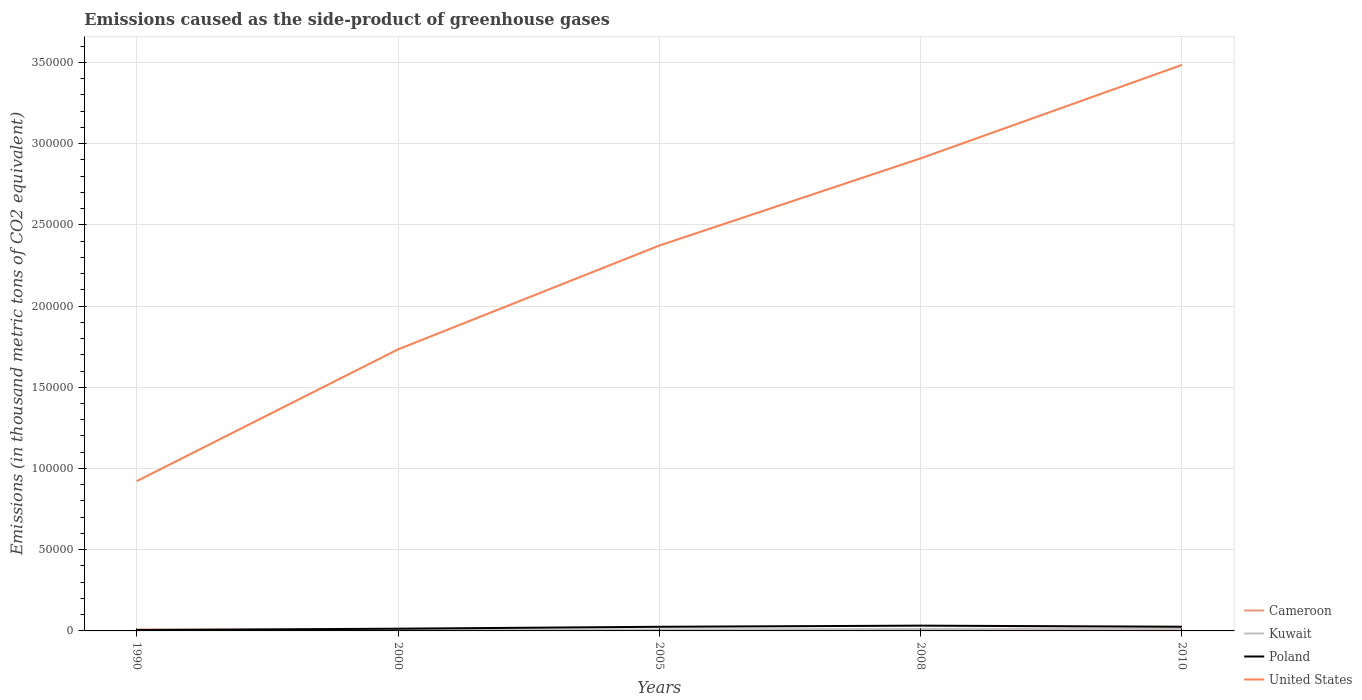Does the line corresponding to Cameroon intersect with the line corresponding to Poland?
Give a very brief answer. Yes. Is the number of lines equal to the number of legend labels?
Ensure brevity in your answer.  Yes. Across all years, what is the maximum emissions caused as the side-product of greenhouse gases in Poland?
Your answer should be very brief. 532.2. What is the total emissions caused as the side-product of greenhouse gases in Poland in the graph?
Your answer should be compact. -844.1. What is the difference between the highest and the second highest emissions caused as the side-product of greenhouse gases in Poland?
Ensure brevity in your answer.  2717.6. What is the difference between the highest and the lowest emissions caused as the side-product of greenhouse gases in Cameroon?
Give a very brief answer. 1. Are the values on the major ticks of Y-axis written in scientific E-notation?
Ensure brevity in your answer.  No. Does the graph contain any zero values?
Provide a short and direct response. No. Where does the legend appear in the graph?
Your response must be concise. Bottom right. How are the legend labels stacked?
Provide a succinct answer. Vertical. What is the title of the graph?
Provide a short and direct response. Emissions caused as the side-product of greenhouse gases. Does "Middle East & North Africa (developing only)" appear as one of the legend labels in the graph?
Offer a very short reply. No. What is the label or title of the X-axis?
Your answer should be very brief. Years. What is the label or title of the Y-axis?
Your answer should be very brief. Emissions (in thousand metric tons of CO2 equivalent). What is the Emissions (in thousand metric tons of CO2 equivalent) of Cameroon in 1990?
Ensure brevity in your answer.  932.3. What is the Emissions (in thousand metric tons of CO2 equivalent) of Kuwait in 1990?
Keep it short and to the point. 263.1. What is the Emissions (in thousand metric tons of CO2 equivalent) in Poland in 1990?
Your response must be concise. 532.2. What is the Emissions (in thousand metric tons of CO2 equivalent) in United States in 1990?
Give a very brief answer. 9.22e+04. What is the Emissions (in thousand metric tons of CO2 equivalent) in Cameroon in 2000?
Your answer should be compact. 514.7. What is the Emissions (in thousand metric tons of CO2 equivalent) of Kuwait in 2000?
Make the answer very short. 498.2. What is the Emissions (in thousand metric tons of CO2 equivalent) of Poland in 2000?
Offer a very short reply. 1376.3. What is the Emissions (in thousand metric tons of CO2 equivalent) in United States in 2000?
Offer a terse response. 1.73e+05. What is the Emissions (in thousand metric tons of CO2 equivalent) in Cameroon in 2005?
Ensure brevity in your answer.  417.5. What is the Emissions (in thousand metric tons of CO2 equivalent) of Kuwait in 2005?
Your answer should be very brief. 925.6. What is the Emissions (in thousand metric tons of CO2 equivalent) of Poland in 2005?
Offer a terse response. 2547.9. What is the Emissions (in thousand metric tons of CO2 equivalent) of United States in 2005?
Your response must be concise. 2.37e+05. What is the Emissions (in thousand metric tons of CO2 equivalent) in Cameroon in 2008?
Ensure brevity in your answer.  422.1. What is the Emissions (in thousand metric tons of CO2 equivalent) in Kuwait in 2008?
Offer a terse response. 1235.4. What is the Emissions (in thousand metric tons of CO2 equivalent) in Poland in 2008?
Provide a succinct answer. 3249.8. What is the Emissions (in thousand metric tons of CO2 equivalent) in United States in 2008?
Give a very brief answer. 2.91e+05. What is the Emissions (in thousand metric tons of CO2 equivalent) in Cameroon in 2010?
Keep it short and to the point. 353. What is the Emissions (in thousand metric tons of CO2 equivalent) in Kuwait in 2010?
Provide a succinct answer. 1451. What is the Emissions (in thousand metric tons of CO2 equivalent) of Poland in 2010?
Your response must be concise. 2582. What is the Emissions (in thousand metric tons of CO2 equivalent) of United States in 2010?
Your answer should be very brief. 3.48e+05. Across all years, what is the maximum Emissions (in thousand metric tons of CO2 equivalent) of Cameroon?
Give a very brief answer. 932.3. Across all years, what is the maximum Emissions (in thousand metric tons of CO2 equivalent) in Kuwait?
Ensure brevity in your answer.  1451. Across all years, what is the maximum Emissions (in thousand metric tons of CO2 equivalent) in Poland?
Make the answer very short. 3249.8. Across all years, what is the maximum Emissions (in thousand metric tons of CO2 equivalent) of United States?
Give a very brief answer. 3.48e+05. Across all years, what is the minimum Emissions (in thousand metric tons of CO2 equivalent) of Cameroon?
Make the answer very short. 353. Across all years, what is the minimum Emissions (in thousand metric tons of CO2 equivalent) of Kuwait?
Your answer should be very brief. 263.1. Across all years, what is the minimum Emissions (in thousand metric tons of CO2 equivalent) in Poland?
Make the answer very short. 532.2. Across all years, what is the minimum Emissions (in thousand metric tons of CO2 equivalent) of United States?
Your response must be concise. 9.22e+04. What is the total Emissions (in thousand metric tons of CO2 equivalent) in Cameroon in the graph?
Your answer should be compact. 2639.6. What is the total Emissions (in thousand metric tons of CO2 equivalent) of Kuwait in the graph?
Give a very brief answer. 4373.3. What is the total Emissions (in thousand metric tons of CO2 equivalent) of Poland in the graph?
Your answer should be very brief. 1.03e+04. What is the total Emissions (in thousand metric tons of CO2 equivalent) of United States in the graph?
Your answer should be very brief. 1.14e+06. What is the difference between the Emissions (in thousand metric tons of CO2 equivalent) of Cameroon in 1990 and that in 2000?
Your response must be concise. 417.6. What is the difference between the Emissions (in thousand metric tons of CO2 equivalent) in Kuwait in 1990 and that in 2000?
Give a very brief answer. -235.1. What is the difference between the Emissions (in thousand metric tons of CO2 equivalent) in Poland in 1990 and that in 2000?
Provide a short and direct response. -844.1. What is the difference between the Emissions (in thousand metric tons of CO2 equivalent) in United States in 1990 and that in 2000?
Provide a short and direct response. -8.11e+04. What is the difference between the Emissions (in thousand metric tons of CO2 equivalent) of Cameroon in 1990 and that in 2005?
Provide a succinct answer. 514.8. What is the difference between the Emissions (in thousand metric tons of CO2 equivalent) of Kuwait in 1990 and that in 2005?
Make the answer very short. -662.5. What is the difference between the Emissions (in thousand metric tons of CO2 equivalent) of Poland in 1990 and that in 2005?
Offer a very short reply. -2015.7. What is the difference between the Emissions (in thousand metric tons of CO2 equivalent) in United States in 1990 and that in 2005?
Offer a terse response. -1.45e+05. What is the difference between the Emissions (in thousand metric tons of CO2 equivalent) in Cameroon in 1990 and that in 2008?
Keep it short and to the point. 510.2. What is the difference between the Emissions (in thousand metric tons of CO2 equivalent) in Kuwait in 1990 and that in 2008?
Your response must be concise. -972.3. What is the difference between the Emissions (in thousand metric tons of CO2 equivalent) in Poland in 1990 and that in 2008?
Give a very brief answer. -2717.6. What is the difference between the Emissions (in thousand metric tons of CO2 equivalent) of United States in 1990 and that in 2008?
Offer a very short reply. -1.99e+05. What is the difference between the Emissions (in thousand metric tons of CO2 equivalent) in Cameroon in 1990 and that in 2010?
Your response must be concise. 579.3. What is the difference between the Emissions (in thousand metric tons of CO2 equivalent) of Kuwait in 1990 and that in 2010?
Provide a short and direct response. -1187.9. What is the difference between the Emissions (in thousand metric tons of CO2 equivalent) in Poland in 1990 and that in 2010?
Ensure brevity in your answer.  -2049.8. What is the difference between the Emissions (in thousand metric tons of CO2 equivalent) of United States in 1990 and that in 2010?
Your answer should be very brief. -2.56e+05. What is the difference between the Emissions (in thousand metric tons of CO2 equivalent) in Cameroon in 2000 and that in 2005?
Keep it short and to the point. 97.2. What is the difference between the Emissions (in thousand metric tons of CO2 equivalent) in Kuwait in 2000 and that in 2005?
Make the answer very short. -427.4. What is the difference between the Emissions (in thousand metric tons of CO2 equivalent) in Poland in 2000 and that in 2005?
Keep it short and to the point. -1171.6. What is the difference between the Emissions (in thousand metric tons of CO2 equivalent) in United States in 2000 and that in 2005?
Offer a terse response. -6.39e+04. What is the difference between the Emissions (in thousand metric tons of CO2 equivalent) in Cameroon in 2000 and that in 2008?
Offer a terse response. 92.6. What is the difference between the Emissions (in thousand metric tons of CO2 equivalent) of Kuwait in 2000 and that in 2008?
Your answer should be very brief. -737.2. What is the difference between the Emissions (in thousand metric tons of CO2 equivalent) of Poland in 2000 and that in 2008?
Make the answer very short. -1873.5. What is the difference between the Emissions (in thousand metric tons of CO2 equivalent) in United States in 2000 and that in 2008?
Your answer should be very brief. -1.18e+05. What is the difference between the Emissions (in thousand metric tons of CO2 equivalent) of Cameroon in 2000 and that in 2010?
Give a very brief answer. 161.7. What is the difference between the Emissions (in thousand metric tons of CO2 equivalent) in Kuwait in 2000 and that in 2010?
Your response must be concise. -952.8. What is the difference between the Emissions (in thousand metric tons of CO2 equivalent) of Poland in 2000 and that in 2010?
Make the answer very short. -1205.7. What is the difference between the Emissions (in thousand metric tons of CO2 equivalent) of United States in 2000 and that in 2010?
Offer a very short reply. -1.75e+05. What is the difference between the Emissions (in thousand metric tons of CO2 equivalent) of Kuwait in 2005 and that in 2008?
Your answer should be compact. -309.8. What is the difference between the Emissions (in thousand metric tons of CO2 equivalent) of Poland in 2005 and that in 2008?
Keep it short and to the point. -701.9. What is the difference between the Emissions (in thousand metric tons of CO2 equivalent) in United States in 2005 and that in 2008?
Provide a succinct answer. -5.37e+04. What is the difference between the Emissions (in thousand metric tons of CO2 equivalent) in Cameroon in 2005 and that in 2010?
Offer a terse response. 64.5. What is the difference between the Emissions (in thousand metric tons of CO2 equivalent) in Kuwait in 2005 and that in 2010?
Make the answer very short. -525.4. What is the difference between the Emissions (in thousand metric tons of CO2 equivalent) in Poland in 2005 and that in 2010?
Ensure brevity in your answer.  -34.1. What is the difference between the Emissions (in thousand metric tons of CO2 equivalent) in United States in 2005 and that in 2010?
Offer a very short reply. -1.11e+05. What is the difference between the Emissions (in thousand metric tons of CO2 equivalent) in Cameroon in 2008 and that in 2010?
Your response must be concise. 69.1. What is the difference between the Emissions (in thousand metric tons of CO2 equivalent) of Kuwait in 2008 and that in 2010?
Your answer should be compact. -215.6. What is the difference between the Emissions (in thousand metric tons of CO2 equivalent) of Poland in 2008 and that in 2010?
Ensure brevity in your answer.  667.8. What is the difference between the Emissions (in thousand metric tons of CO2 equivalent) of United States in 2008 and that in 2010?
Provide a short and direct response. -5.75e+04. What is the difference between the Emissions (in thousand metric tons of CO2 equivalent) of Cameroon in 1990 and the Emissions (in thousand metric tons of CO2 equivalent) of Kuwait in 2000?
Make the answer very short. 434.1. What is the difference between the Emissions (in thousand metric tons of CO2 equivalent) in Cameroon in 1990 and the Emissions (in thousand metric tons of CO2 equivalent) in Poland in 2000?
Offer a very short reply. -444. What is the difference between the Emissions (in thousand metric tons of CO2 equivalent) in Cameroon in 1990 and the Emissions (in thousand metric tons of CO2 equivalent) in United States in 2000?
Give a very brief answer. -1.72e+05. What is the difference between the Emissions (in thousand metric tons of CO2 equivalent) of Kuwait in 1990 and the Emissions (in thousand metric tons of CO2 equivalent) of Poland in 2000?
Offer a very short reply. -1113.2. What is the difference between the Emissions (in thousand metric tons of CO2 equivalent) in Kuwait in 1990 and the Emissions (in thousand metric tons of CO2 equivalent) in United States in 2000?
Ensure brevity in your answer.  -1.73e+05. What is the difference between the Emissions (in thousand metric tons of CO2 equivalent) of Poland in 1990 and the Emissions (in thousand metric tons of CO2 equivalent) of United States in 2000?
Ensure brevity in your answer.  -1.73e+05. What is the difference between the Emissions (in thousand metric tons of CO2 equivalent) in Cameroon in 1990 and the Emissions (in thousand metric tons of CO2 equivalent) in Kuwait in 2005?
Give a very brief answer. 6.7. What is the difference between the Emissions (in thousand metric tons of CO2 equivalent) of Cameroon in 1990 and the Emissions (in thousand metric tons of CO2 equivalent) of Poland in 2005?
Your response must be concise. -1615.6. What is the difference between the Emissions (in thousand metric tons of CO2 equivalent) of Cameroon in 1990 and the Emissions (in thousand metric tons of CO2 equivalent) of United States in 2005?
Provide a succinct answer. -2.36e+05. What is the difference between the Emissions (in thousand metric tons of CO2 equivalent) of Kuwait in 1990 and the Emissions (in thousand metric tons of CO2 equivalent) of Poland in 2005?
Keep it short and to the point. -2284.8. What is the difference between the Emissions (in thousand metric tons of CO2 equivalent) in Kuwait in 1990 and the Emissions (in thousand metric tons of CO2 equivalent) in United States in 2005?
Provide a succinct answer. -2.37e+05. What is the difference between the Emissions (in thousand metric tons of CO2 equivalent) of Poland in 1990 and the Emissions (in thousand metric tons of CO2 equivalent) of United States in 2005?
Keep it short and to the point. -2.37e+05. What is the difference between the Emissions (in thousand metric tons of CO2 equivalent) of Cameroon in 1990 and the Emissions (in thousand metric tons of CO2 equivalent) of Kuwait in 2008?
Make the answer very short. -303.1. What is the difference between the Emissions (in thousand metric tons of CO2 equivalent) of Cameroon in 1990 and the Emissions (in thousand metric tons of CO2 equivalent) of Poland in 2008?
Give a very brief answer. -2317.5. What is the difference between the Emissions (in thousand metric tons of CO2 equivalent) of Cameroon in 1990 and the Emissions (in thousand metric tons of CO2 equivalent) of United States in 2008?
Your response must be concise. -2.90e+05. What is the difference between the Emissions (in thousand metric tons of CO2 equivalent) in Kuwait in 1990 and the Emissions (in thousand metric tons of CO2 equivalent) in Poland in 2008?
Your answer should be compact. -2986.7. What is the difference between the Emissions (in thousand metric tons of CO2 equivalent) in Kuwait in 1990 and the Emissions (in thousand metric tons of CO2 equivalent) in United States in 2008?
Provide a short and direct response. -2.91e+05. What is the difference between the Emissions (in thousand metric tons of CO2 equivalent) in Poland in 1990 and the Emissions (in thousand metric tons of CO2 equivalent) in United States in 2008?
Your answer should be compact. -2.90e+05. What is the difference between the Emissions (in thousand metric tons of CO2 equivalent) in Cameroon in 1990 and the Emissions (in thousand metric tons of CO2 equivalent) in Kuwait in 2010?
Provide a short and direct response. -518.7. What is the difference between the Emissions (in thousand metric tons of CO2 equivalent) in Cameroon in 1990 and the Emissions (in thousand metric tons of CO2 equivalent) in Poland in 2010?
Keep it short and to the point. -1649.7. What is the difference between the Emissions (in thousand metric tons of CO2 equivalent) of Cameroon in 1990 and the Emissions (in thousand metric tons of CO2 equivalent) of United States in 2010?
Your response must be concise. -3.48e+05. What is the difference between the Emissions (in thousand metric tons of CO2 equivalent) of Kuwait in 1990 and the Emissions (in thousand metric tons of CO2 equivalent) of Poland in 2010?
Your answer should be compact. -2318.9. What is the difference between the Emissions (in thousand metric tons of CO2 equivalent) of Kuwait in 1990 and the Emissions (in thousand metric tons of CO2 equivalent) of United States in 2010?
Make the answer very short. -3.48e+05. What is the difference between the Emissions (in thousand metric tons of CO2 equivalent) of Poland in 1990 and the Emissions (in thousand metric tons of CO2 equivalent) of United States in 2010?
Offer a very short reply. -3.48e+05. What is the difference between the Emissions (in thousand metric tons of CO2 equivalent) of Cameroon in 2000 and the Emissions (in thousand metric tons of CO2 equivalent) of Kuwait in 2005?
Your answer should be very brief. -410.9. What is the difference between the Emissions (in thousand metric tons of CO2 equivalent) in Cameroon in 2000 and the Emissions (in thousand metric tons of CO2 equivalent) in Poland in 2005?
Your answer should be very brief. -2033.2. What is the difference between the Emissions (in thousand metric tons of CO2 equivalent) in Cameroon in 2000 and the Emissions (in thousand metric tons of CO2 equivalent) in United States in 2005?
Offer a terse response. -2.37e+05. What is the difference between the Emissions (in thousand metric tons of CO2 equivalent) of Kuwait in 2000 and the Emissions (in thousand metric tons of CO2 equivalent) of Poland in 2005?
Keep it short and to the point. -2049.7. What is the difference between the Emissions (in thousand metric tons of CO2 equivalent) in Kuwait in 2000 and the Emissions (in thousand metric tons of CO2 equivalent) in United States in 2005?
Offer a terse response. -2.37e+05. What is the difference between the Emissions (in thousand metric tons of CO2 equivalent) of Poland in 2000 and the Emissions (in thousand metric tons of CO2 equivalent) of United States in 2005?
Your answer should be very brief. -2.36e+05. What is the difference between the Emissions (in thousand metric tons of CO2 equivalent) of Cameroon in 2000 and the Emissions (in thousand metric tons of CO2 equivalent) of Kuwait in 2008?
Keep it short and to the point. -720.7. What is the difference between the Emissions (in thousand metric tons of CO2 equivalent) in Cameroon in 2000 and the Emissions (in thousand metric tons of CO2 equivalent) in Poland in 2008?
Give a very brief answer. -2735.1. What is the difference between the Emissions (in thousand metric tons of CO2 equivalent) of Cameroon in 2000 and the Emissions (in thousand metric tons of CO2 equivalent) of United States in 2008?
Ensure brevity in your answer.  -2.90e+05. What is the difference between the Emissions (in thousand metric tons of CO2 equivalent) in Kuwait in 2000 and the Emissions (in thousand metric tons of CO2 equivalent) in Poland in 2008?
Your answer should be compact. -2751.6. What is the difference between the Emissions (in thousand metric tons of CO2 equivalent) of Kuwait in 2000 and the Emissions (in thousand metric tons of CO2 equivalent) of United States in 2008?
Offer a terse response. -2.90e+05. What is the difference between the Emissions (in thousand metric tons of CO2 equivalent) of Poland in 2000 and the Emissions (in thousand metric tons of CO2 equivalent) of United States in 2008?
Offer a very short reply. -2.90e+05. What is the difference between the Emissions (in thousand metric tons of CO2 equivalent) in Cameroon in 2000 and the Emissions (in thousand metric tons of CO2 equivalent) in Kuwait in 2010?
Provide a short and direct response. -936.3. What is the difference between the Emissions (in thousand metric tons of CO2 equivalent) of Cameroon in 2000 and the Emissions (in thousand metric tons of CO2 equivalent) of Poland in 2010?
Your answer should be very brief. -2067.3. What is the difference between the Emissions (in thousand metric tons of CO2 equivalent) in Cameroon in 2000 and the Emissions (in thousand metric tons of CO2 equivalent) in United States in 2010?
Offer a very short reply. -3.48e+05. What is the difference between the Emissions (in thousand metric tons of CO2 equivalent) in Kuwait in 2000 and the Emissions (in thousand metric tons of CO2 equivalent) in Poland in 2010?
Provide a succinct answer. -2083.8. What is the difference between the Emissions (in thousand metric tons of CO2 equivalent) in Kuwait in 2000 and the Emissions (in thousand metric tons of CO2 equivalent) in United States in 2010?
Your response must be concise. -3.48e+05. What is the difference between the Emissions (in thousand metric tons of CO2 equivalent) of Poland in 2000 and the Emissions (in thousand metric tons of CO2 equivalent) of United States in 2010?
Ensure brevity in your answer.  -3.47e+05. What is the difference between the Emissions (in thousand metric tons of CO2 equivalent) of Cameroon in 2005 and the Emissions (in thousand metric tons of CO2 equivalent) of Kuwait in 2008?
Give a very brief answer. -817.9. What is the difference between the Emissions (in thousand metric tons of CO2 equivalent) of Cameroon in 2005 and the Emissions (in thousand metric tons of CO2 equivalent) of Poland in 2008?
Your answer should be very brief. -2832.3. What is the difference between the Emissions (in thousand metric tons of CO2 equivalent) in Cameroon in 2005 and the Emissions (in thousand metric tons of CO2 equivalent) in United States in 2008?
Provide a short and direct response. -2.91e+05. What is the difference between the Emissions (in thousand metric tons of CO2 equivalent) of Kuwait in 2005 and the Emissions (in thousand metric tons of CO2 equivalent) of Poland in 2008?
Your response must be concise. -2324.2. What is the difference between the Emissions (in thousand metric tons of CO2 equivalent) in Kuwait in 2005 and the Emissions (in thousand metric tons of CO2 equivalent) in United States in 2008?
Your response must be concise. -2.90e+05. What is the difference between the Emissions (in thousand metric tons of CO2 equivalent) in Poland in 2005 and the Emissions (in thousand metric tons of CO2 equivalent) in United States in 2008?
Offer a very short reply. -2.88e+05. What is the difference between the Emissions (in thousand metric tons of CO2 equivalent) in Cameroon in 2005 and the Emissions (in thousand metric tons of CO2 equivalent) in Kuwait in 2010?
Make the answer very short. -1033.5. What is the difference between the Emissions (in thousand metric tons of CO2 equivalent) in Cameroon in 2005 and the Emissions (in thousand metric tons of CO2 equivalent) in Poland in 2010?
Keep it short and to the point. -2164.5. What is the difference between the Emissions (in thousand metric tons of CO2 equivalent) in Cameroon in 2005 and the Emissions (in thousand metric tons of CO2 equivalent) in United States in 2010?
Ensure brevity in your answer.  -3.48e+05. What is the difference between the Emissions (in thousand metric tons of CO2 equivalent) in Kuwait in 2005 and the Emissions (in thousand metric tons of CO2 equivalent) in Poland in 2010?
Provide a succinct answer. -1656.4. What is the difference between the Emissions (in thousand metric tons of CO2 equivalent) in Kuwait in 2005 and the Emissions (in thousand metric tons of CO2 equivalent) in United States in 2010?
Your response must be concise. -3.48e+05. What is the difference between the Emissions (in thousand metric tons of CO2 equivalent) in Poland in 2005 and the Emissions (in thousand metric tons of CO2 equivalent) in United States in 2010?
Your answer should be very brief. -3.46e+05. What is the difference between the Emissions (in thousand metric tons of CO2 equivalent) of Cameroon in 2008 and the Emissions (in thousand metric tons of CO2 equivalent) of Kuwait in 2010?
Give a very brief answer. -1028.9. What is the difference between the Emissions (in thousand metric tons of CO2 equivalent) of Cameroon in 2008 and the Emissions (in thousand metric tons of CO2 equivalent) of Poland in 2010?
Your response must be concise. -2159.9. What is the difference between the Emissions (in thousand metric tons of CO2 equivalent) in Cameroon in 2008 and the Emissions (in thousand metric tons of CO2 equivalent) in United States in 2010?
Provide a succinct answer. -3.48e+05. What is the difference between the Emissions (in thousand metric tons of CO2 equivalent) in Kuwait in 2008 and the Emissions (in thousand metric tons of CO2 equivalent) in Poland in 2010?
Give a very brief answer. -1346.6. What is the difference between the Emissions (in thousand metric tons of CO2 equivalent) in Kuwait in 2008 and the Emissions (in thousand metric tons of CO2 equivalent) in United States in 2010?
Provide a short and direct response. -3.47e+05. What is the difference between the Emissions (in thousand metric tons of CO2 equivalent) in Poland in 2008 and the Emissions (in thousand metric tons of CO2 equivalent) in United States in 2010?
Your answer should be very brief. -3.45e+05. What is the average Emissions (in thousand metric tons of CO2 equivalent) of Cameroon per year?
Provide a succinct answer. 527.92. What is the average Emissions (in thousand metric tons of CO2 equivalent) in Kuwait per year?
Your answer should be compact. 874.66. What is the average Emissions (in thousand metric tons of CO2 equivalent) of Poland per year?
Provide a short and direct response. 2057.64. What is the average Emissions (in thousand metric tons of CO2 equivalent) in United States per year?
Make the answer very short. 2.28e+05. In the year 1990, what is the difference between the Emissions (in thousand metric tons of CO2 equivalent) in Cameroon and Emissions (in thousand metric tons of CO2 equivalent) in Kuwait?
Provide a succinct answer. 669.2. In the year 1990, what is the difference between the Emissions (in thousand metric tons of CO2 equivalent) of Cameroon and Emissions (in thousand metric tons of CO2 equivalent) of Poland?
Offer a very short reply. 400.1. In the year 1990, what is the difference between the Emissions (in thousand metric tons of CO2 equivalent) of Cameroon and Emissions (in thousand metric tons of CO2 equivalent) of United States?
Give a very brief answer. -9.13e+04. In the year 1990, what is the difference between the Emissions (in thousand metric tons of CO2 equivalent) in Kuwait and Emissions (in thousand metric tons of CO2 equivalent) in Poland?
Your response must be concise. -269.1. In the year 1990, what is the difference between the Emissions (in thousand metric tons of CO2 equivalent) in Kuwait and Emissions (in thousand metric tons of CO2 equivalent) in United States?
Provide a short and direct response. -9.19e+04. In the year 1990, what is the difference between the Emissions (in thousand metric tons of CO2 equivalent) in Poland and Emissions (in thousand metric tons of CO2 equivalent) in United States?
Your response must be concise. -9.17e+04. In the year 2000, what is the difference between the Emissions (in thousand metric tons of CO2 equivalent) of Cameroon and Emissions (in thousand metric tons of CO2 equivalent) of Poland?
Ensure brevity in your answer.  -861.6. In the year 2000, what is the difference between the Emissions (in thousand metric tons of CO2 equivalent) of Cameroon and Emissions (in thousand metric tons of CO2 equivalent) of United States?
Keep it short and to the point. -1.73e+05. In the year 2000, what is the difference between the Emissions (in thousand metric tons of CO2 equivalent) in Kuwait and Emissions (in thousand metric tons of CO2 equivalent) in Poland?
Ensure brevity in your answer.  -878.1. In the year 2000, what is the difference between the Emissions (in thousand metric tons of CO2 equivalent) in Kuwait and Emissions (in thousand metric tons of CO2 equivalent) in United States?
Your response must be concise. -1.73e+05. In the year 2000, what is the difference between the Emissions (in thousand metric tons of CO2 equivalent) in Poland and Emissions (in thousand metric tons of CO2 equivalent) in United States?
Offer a terse response. -1.72e+05. In the year 2005, what is the difference between the Emissions (in thousand metric tons of CO2 equivalent) of Cameroon and Emissions (in thousand metric tons of CO2 equivalent) of Kuwait?
Keep it short and to the point. -508.1. In the year 2005, what is the difference between the Emissions (in thousand metric tons of CO2 equivalent) in Cameroon and Emissions (in thousand metric tons of CO2 equivalent) in Poland?
Your answer should be compact. -2130.4. In the year 2005, what is the difference between the Emissions (in thousand metric tons of CO2 equivalent) in Cameroon and Emissions (in thousand metric tons of CO2 equivalent) in United States?
Keep it short and to the point. -2.37e+05. In the year 2005, what is the difference between the Emissions (in thousand metric tons of CO2 equivalent) in Kuwait and Emissions (in thousand metric tons of CO2 equivalent) in Poland?
Keep it short and to the point. -1622.3. In the year 2005, what is the difference between the Emissions (in thousand metric tons of CO2 equivalent) of Kuwait and Emissions (in thousand metric tons of CO2 equivalent) of United States?
Keep it short and to the point. -2.36e+05. In the year 2005, what is the difference between the Emissions (in thousand metric tons of CO2 equivalent) in Poland and Emissions (in thousand metric tons of CO2 equivalent) in United States?
Make the answer very short. -2.35e+05. In the year 2008, what is the difference between the Emissions (in thousand metric tons of CO2 equivalent) of Cameroon and Emissions (in thousand metric tons of CO2 equivalent) of Kuwait?
Give a very brief answer. -813.3. In the year 2008, what is the difference between the Emissions (in thousand metric tons of CO2 equivalent) of Cameroon and Emissions (in thousand metric tons of CO2 equivalent) of Poland?
Keep it short and to the point. -2827.7. In the year 2008, what is the difference between the Emissions (in thousand metric tons of CO2 equivalent) in Cameroon and Emissions (in thousand metric tons of CO2 equivalent) in United States?
Keep it short and to the point. -2.90e+05. In the year 2008, what is the difference between the Emissions (in thousand metric tons of CO2 equivalent) of Kuwait and Emissions (in thousand metric tons of CO2 equivalent) of Poland?
Your answer should be very brief. -2014.4. In the year 2008, what is the difference between the Emissions (in thousand metric tons of CO2 equivalent) in Kuwait and Emissions (in thousand metric tons of CO2 equivalent) in United States?
Ensure brevity in your answer.  -2.90e+05. In the year 2008, what is the difference between the Emissions (in thousand metric tons of CO2 equivalent) of Poland and Emissions (in thousand metric tons of CO2 equivalent) of United States?
Give a very brief answer. -2.88e+05. In the year 2010, what is the difference between the Emissions (in thousand metric tons of CO2 equivalent) in Cameroon and Emissions (in thousand metric tons of CO2 equivalent) in Kuwait?
Ensure brevity in your answer.  -1098. In the year 2010, what is the difference between the Emissions (in thousand metric tons of CO2 equivalent) of Cameroon and Emissions (in thousand metric tons of CO2 equivalent) of Poland?
Make the answer very short. -2229. In the year 2010, what is the difference between the Emissions (in thousand metric tons of CO2 equivalent) of Cameroon and Emissions (in thousand metric tons of CO2 equivalent) of United States?
Provide a succinct answer. -3.48e+05. In the year 2010, what is the difference between the Emissions (in thousand metric tons of CO2 equivalent) of Kuwait and Emissions (in thousand metric tons of CO2 equivalent) of Poland?
Provide a short and direct response. -1131. In the year 2010, what is the difference between the Emissions (in thousand metric tons of CO2 equivalent) in Kuwait and Emissions (in thousand metric tons of CO2 equivalent) in United States?
Provide a short and direct response. -3.47e+05. In the year 2010, what is the difference between the Emissions (in thousand metric tons of CO2 equivalent) in Poland and Emissions (in thousand metric tons of CO2 equivalent) in United States?
Offer a very short reply. -3.46e+05. What is the ratio of the Emissions (in thousand metric tons of CO2 equivalent) of Cameroon in 1990 to that in 2000?
Offer a very short reply. 1.81. What is the ratio of the Emissions (in thousand metric tons of CO2 equivalent) of Kuwait in 1990 to that in 2000?
Give a very brief answer. 0.53. What is the ratio of the Emissions (in thousand metric tons of CO2 equivalent) in Poland in 1990 to that in 2000?
Your response must be concise. 0.39. What is the ratio of the Emissions (in thousand metric tons of CO2 equivalent) in United States in 1990 to that in 2000?
Your response must be concise. 0.53. What is the ratio of the Emissions (in thousand metric tons of CO2 equivalent) in Cameroon in 1990 to that in 2005?
Your answer should be very brief. 2.23. What is the ratio of the Emissions (in thousand metric tons of CO2 equivalent) in Kuwait in 1990 to that in 2005?
Give a very brief answer. 0.28. What is the ratio of the Emissions (in thousand metric tons of CO2 equivalent) in Poland in 1990 to that in 2005?
Provide a short and direct response. 0.21. What is the ratio of the Emissions (in thousand metric tons of CO2 equivalent) in United States in 1990 to that in 2005?
Keep it short and to the point. 0.39. What is the ratio of the Emissions (in thousand metric tons of CO2 equivalent) in Cameroon in 1990 to that in 2008?
Provide a succinct answer. 2.21. What is the ratio of the Emissions (in thousand metric tons of CO2 equivalent) in Kuwait in 1990 to that in 2008?
Provide a succinct answer. 0.21. What is the ratio of the Emissions (in thousand metric tons of CO2 equivalent) in Poland in 1990 to that in 2008?
Give a very brief answer. 0.16. What is the ratio of the Emissions (in thousand metric tons of CO2 equivalent) in United States in 1990 to that in 2008?
Your response must be concise. 0.32. What is the ratio of the Emissions (in thousand metric tons of CO2 equivalent) in Cameroon in 1990 to that in 2010?
Provide a short and direct response. 2.64. What is the ratio of the Emissions (in thousand metric tons of CO2 equivalent) in Kuwait in 1990 to that in 2010?
Give a very brief answer. 0.18. What is the ratio of the Emissions (in thousand metric tons of CO2 equivalent) of Poland in 1990 to that in 2010?
Provide a succinct answer. 0.21. What is the ratio of the Emissions (in thousand metric tons of CO2 equivalent) in United States in 1990 to that in 2010?
Your answer should be very brief. 0.26. What is the ratio of the Emissions (in thousand metric tons of CO2 equivalent) of Cameroon in 2000 to that in 2005?
Keep it short and to the point. 1.23. What is the ratio of the Emissions (in thousand metric tons of CO2 equivalent) of Kuwait in 2000 to that in 2005?
Ensure brevity in your answer.  0.54. What is the ratio of the Emissions (in thousand metric tons of CO2 equivalent) in Poland in 2000 to that in 2005?
Make the answer very short. 0.54. What is the ratio of the Emissions (in thousand metric tons of CO2 equivalent) in United States in 2000 to that in 2005?
Provide a short and direct response. 0.73. What is the ratio of the Emissions (in thousand metric tons of CO2 equivalent) in Cameroon in 2000 to that in 2008?
Give a very brief answer. 1.22. What is the ratio of the Emissions (in thousand metric tons of CO2 equivalent) of Kuwait in 2000 to that in 2008?
Your answer should be very brief. 0.4. What is the ratio of the Emissions (in thousand metric tons of CO2 equivalent) of Poland in 2000 to that in 2008?
Your response must be concise. 0.42. What is the ratio of the Emissions (in thousand metric tons of CO2 equivalent) in United States in 2000 to that in 2008?
Offer a terse response. 0.6. What is the ratio of the Emissions (in thousand metric tons of CO2 equivalent) in Cameroon in 2000 to that in 2010?
Your answer should be very brief. 1.46. What is the ratio of the Emissions (in thousand metric tons of CO2 equivalent) of Kuwait in 2000 to that in 2010?
Offer a terse response. 0.34. What is the ratio of the Emissions (in thousand metric tons of CO2 equivalent) in Poland in 2000 to that in 2010?
Make the answer very short. 0.53. What is the ratio of the Emissions (in thousand metric tons of CO2 equivalent) of United States in 2000 to that in 2010?
Your response must be concise. 0.5. What is the ratio of the Emissions (in thousand metric tons of CO2 equivalent) of Kuwait in 2005 to that in 2008?
Offer a very short reply. 0.75. What is the ratio of the Emissions (in thousand metric tons of CO2 equivalent) of Poland in 2005 to that in 2008?
Offer a very short reply. 0.78. What is the ratio of the Emissions (in thousand metric tons of CO2 equivalent) in United States in 2005 to that in 2008?
Give a very brief answer. 0.82. What is the ratio of the Emissions (in thousand metric tons of CO2 equivalent) of Cameroon in 2005 to that in 2010?
Your response must be concise. 1.18. What is the ratio of the Emissions (in thousand metric tons of CO2 equivalent) in Kuwait in 2005 to that in 2010?
Offer a terse response. 0.64. What is the ratio of the Emissions (in thousand metric tons of CO2 equivalent) in Poland in 2005 to that in 2010?
Give a very brief answer. 0.99. What is the ratio of the Emissions (in thousand metric tons of CO2 equivalent) in United States in 2005 to that in 2010?
Your answer should be very brief. 0.68. What is the ratio of the Emissions (in thousand metric tons of CO2 equivalent) in Cameroon in 2008 to that in 2010?
Your answer should be very brief. 1.2. What is the ratio of the Emissions (in thousand metric tons of CO2 equivalent) of Kuwait in 2008 to that in 2010?
Provide a short and direct response. 0.85. What is the ratio of the Emissions (in thousand metric tons of CO2 equivalent) in Poland in 2008 to that in 2010?
Give a very brief answer. 1.26. What is the ratio of the Emissions (in thousand metric tons of CO2 equivalent) in United States in 2008 to that in 2010?
Offer a terse response. 0.83. What is the difference between the highest and the second highest Emissions (in thousand metric tons of CO2 equivalent) of Cameroon?
Your answer should be compact. 417.6. What is the difference between the highest and the second highest Emissions (in thousand metric tons of CO2 equivalent) in Kuwait?
Provide a short and direct response. 215.6. What is the difference between the highest and the second highest Emissions (in thousand metric tons of CO2 equivalent) of Poland?
Your answer should be very brief. 667.8. What is the difference between the highest and the second highest Emissions (in thousand metric tons of CO2 equivalent) in United States?
Provide a short and direct response. 5.75e+04. What is the difference between the highest and the lowest Emissions (in thousand metric tons of CO2 equivalent) in Cameroon?
Make the answer very short. 579.3. What is the difference between the highest and the lowest Emissions (in thousand metric tons of CO2 equivalent) of Kuwait?
Your answer should be compact. 1187.9. What is the difference between the highest and the lowest Emissions (in thousand metric tons of CO2 equivalent) of Poland?
Provide a short and direct response. 2717.6. What is the difference between the highest and the lowest Emissions (in thousand metric tons of CO2 equivalent) in United States?
Make the answer very short. 2.56e+05. 